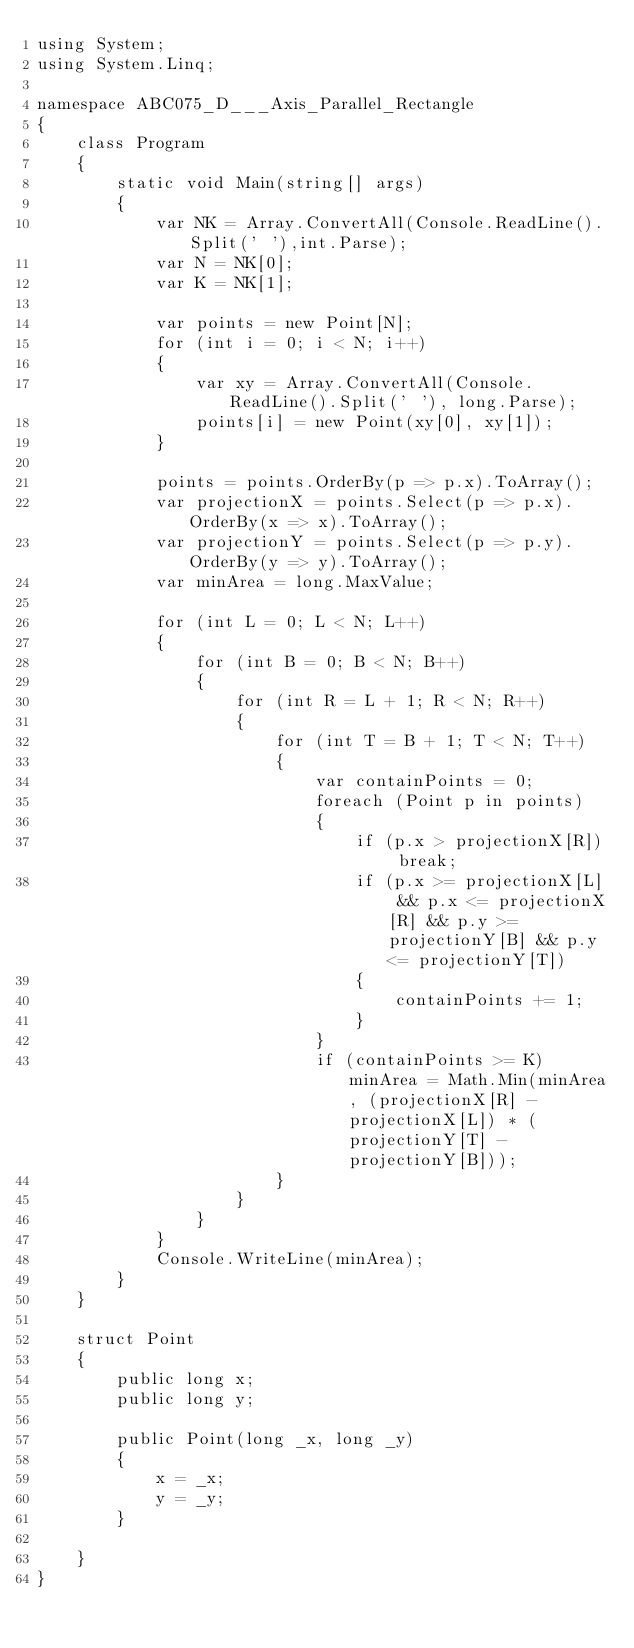Convert code to text. <code><loc_0><loc_0><loc_500><loc_500><_C#_>using System;
using System.Linq;

namespace ABC075_D___Axis_Parallel_Rectangle
{
    class Program
    {
        static void Main(string[] args)
        {
            var NK = Array.ConvertAll(Console.ReadLine().Split(' '),int.Parse);
            var N = NK[0];
            var K = NK[1];

            var points = new Point[N];
            for (int i = 0; i < N; i++)
            {
                var xy = Array.ConvertAll(Console.ReadLine().Split(' '), long.Parse);
                points[i] = new Point(xy[0], xy[1]);
            }

            points = points.OrderBy(p => p.x).ToArray();
            var projectionX = points.Select(p => p.x).OrderBy(x => x).ToArray();
            var projectionY = points.Select(p => p.y).OrderBy(y => y).ToArray();
            var minArea = long.MaxValue;

            for (int L = 0; L < N; L++)
            {
                for (int B = 0; B < N; B++)
                {
                    for (int R = L + 1; R < N; R++)
                    {
                        for (int T = B + 1; T < N; T++)
                        {
                            var containPoints = 0;
                            foreach (Point p in points)
                            {
                                if (p.x > projectionX[R]) break;
                                if (p.x >= projectionX[L] && p.x <= projectionX[R] && p.y >= projectionY[B] && p.y <= projectionY[T])
                                {
                                    containPoints += 1;
                                }
                            }
                            if (containPoints >= K) minArea = Math.Min(minArea, (projectionX[R] - projectionX[L]) * (projectionY[T] - projectionY[B]));
                        }
                    }
                }
            }
            Console.WriteLine(minArea);
        }
    }

    struct Point
    {
        public long x;
        public long y;

        public Point(long _x, long _y)
        {
            x = _x;
            y = _y;
        }

    }
}
</code> 